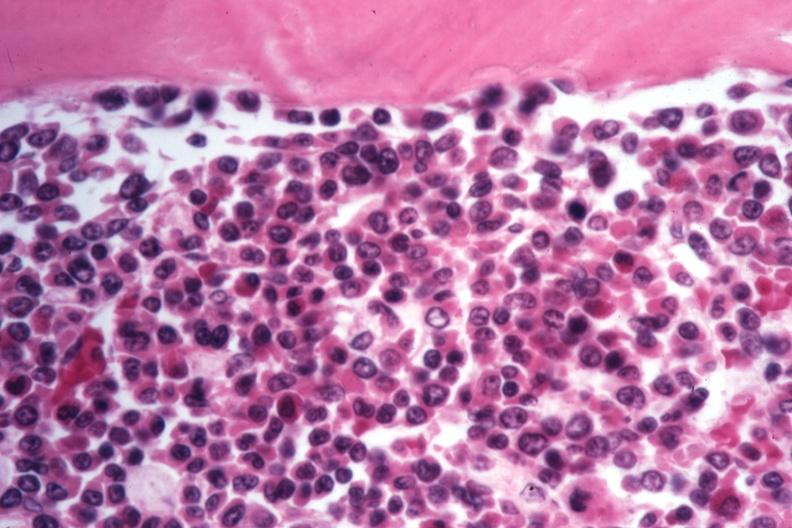does nipples appear to be moving to blast crisis?
Answer the question using a single word or phrase. No 